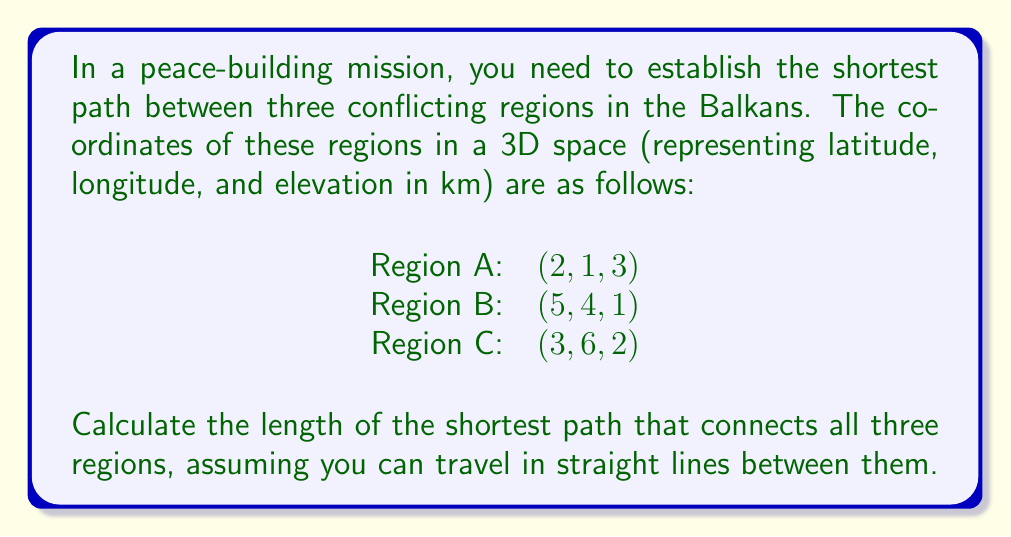Can you solve this math problem? To solve this problem, we need to follow these steps:

1) First, we'll calculate the distances between each pair of points using the distance formula in 3D space:

   $$d = \sqrt{(x_2-x_1)^2 + (y_2-y_1)^2 + (z_2-z_1)^2}$$

2) Let's calculate the distances:

   AB: $$\sqrt{(5-2)^2 + (4-1)^2 + (1-3)^2} = \sqrt{3^2 + 3^2 + (-2)^2} = \sqrt{22}$$

   BC: $$\sqrt{(3-5)^2 + (6-4)^2 + (2-1)^2} = \sqrt{(-2)^2 + 2^2 + 1^2} = \sqrt{9}$$

   AC: $$\sqrt{(3-2)^2 + (6-1)^2 + (2-3)^2} = \sqrt{1^2 + 5^2 + (-1)^2} = \sqrt{27}$$

3) The shortest path that connects all three points will be the sum of the two shortest distances among these three.

4) Comparing the distances:
   AB = $\sqrt{22}$ ≈ 4.69
   BC = $\sqrt{9}$ = 3
   AC = $\sqrt{27}$ ≈ 5.20

5) The two shortest distances are AB and BC.

6) Therefore, the shortest path is:
   $$\sqrt{22} + \sqrt{9} = \sqrt{22} + 3$$

This path goes from A to B, then from B to C.
Answer: $\sqrt{22} + 3$ km 